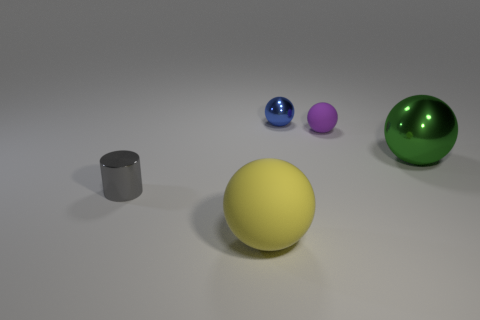There is a purple sphere that is the same size as the gray metallic thing; what is its material?
Give a very brief answer. Rubber. What shape is the purple object?
Provide a short and direct response. Sphere. What number of purple objects are either balls or tiny metallic things?
Give a very brief answer. 1. There is a green object that is made of the same material as the tiny gray thing; what size is it?
Provide a succinct answer. Large. Do the small ball that is on the left side of the purple matte object and the large thing that is on the left side of the small matte sphere have the same material?
Ensure brevity in your answer.  No. How many spheres are purple objects or matte things?
Offer a terse response. 2. There is a tiny object that is on the left side of the small metallic object that is behind the gray metal cylinder; what number of yellow matte balls are behind it?
Keep it short and to the point. 0. There is a green object that is the same shape as the yellow matte object; what material is it?
Keep it short and to the point. Metal. What is the color of the thing on the right side of the purple sphere?
Make the answer very short. Green. Is the material of the tiny purple ball the same as the large object in front of the small cylinder?
Keep it short and to the point. Yes. 